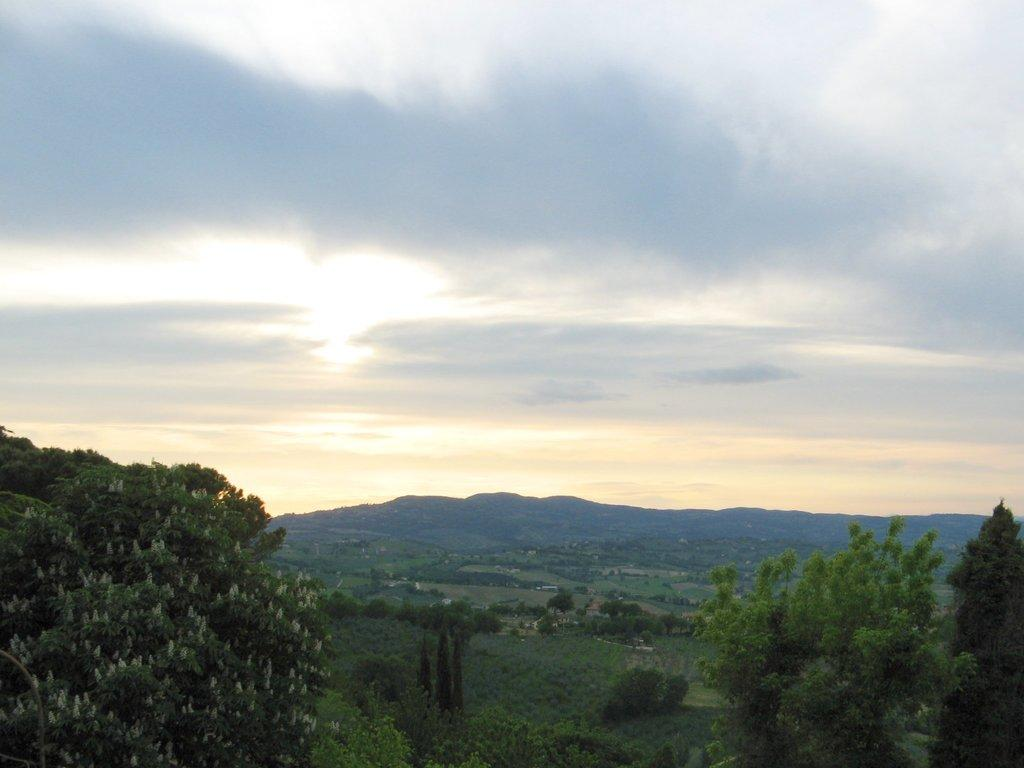What type of view is shown in the image? The image is an outside view. What can be seen on the ground in the image? There are many trees and plants on the ground. What is visible at the top of the image? The sky is visible at the top of the image. What can be observed in the sky? Clouds are present in the sky. Can you tell me where the person is getting their haircut in the image? There is no person getting a haircut in the image; it is an outside view with trees, plants, and clouds. Is there a jail visible in the image? There is no jail present in the image; it features an outside view with trees, plants, and clouds. 